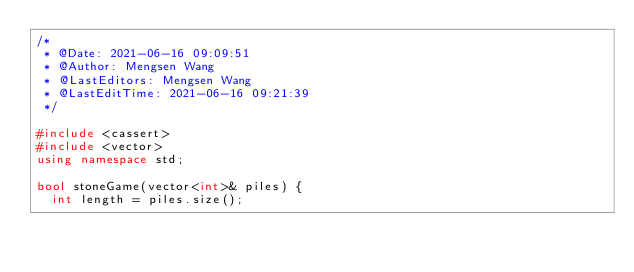<code> <loc_0><loc_0><loc_500><loc_500><_C++_>/*
 * @Date: 2021-06-16 09:09:51
 * @Author: Mengsen Wang
 * @LastEditors: Mengsen Wang
 * @LastEditTime: 2021-06-16 09:21:39
 */

#include <cassert>
#include <vector>
using namespace std;

bool stoneGame(vector<int>& piles) {
  int length = piles.size();</code> 